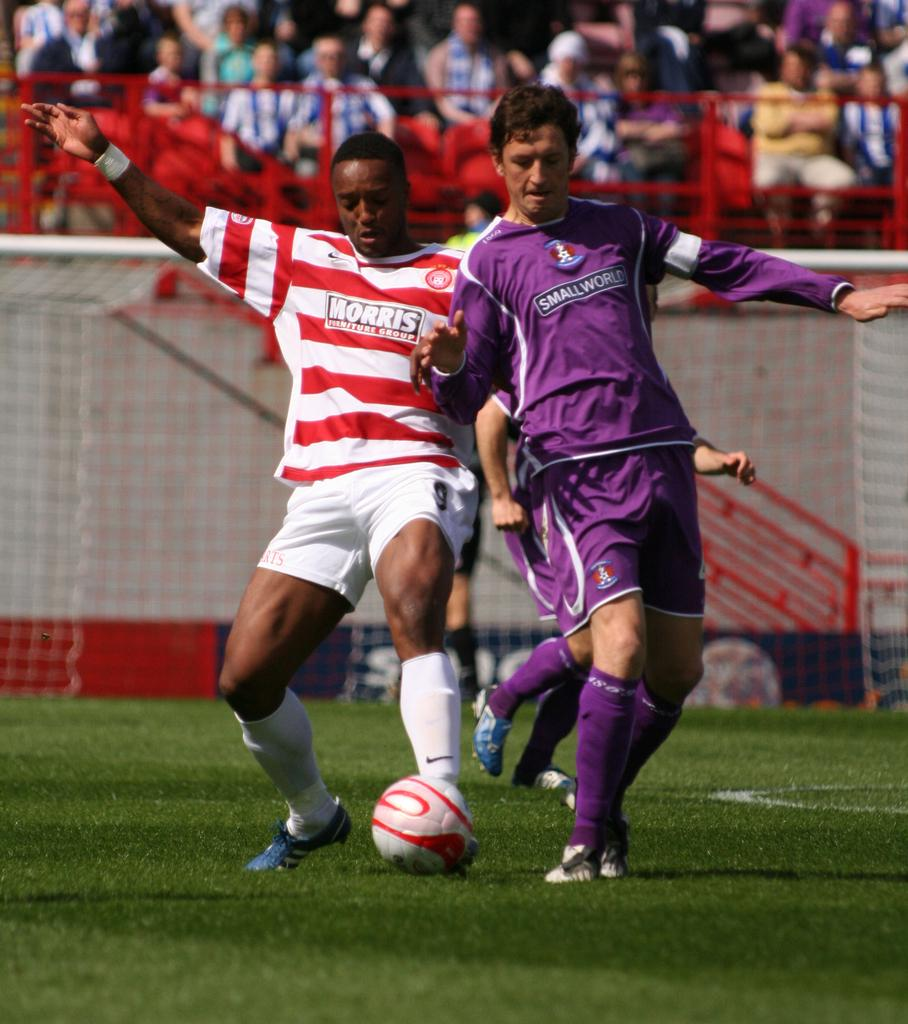What are the two men in the image doing? The two men are playing a game in the image. What is the main object involved in the game? The game involves a ball. Where are the men playing the game? The men are playing on a ground. What can be seen in the background of the image? In the background, there are people seated on chairs. What are the seated people doing? The seated people are watching the game. What type of offer is the man making to the seated people in the image? There is no man making an offer to the seated people in the image; the seated people are simply watching the game. 